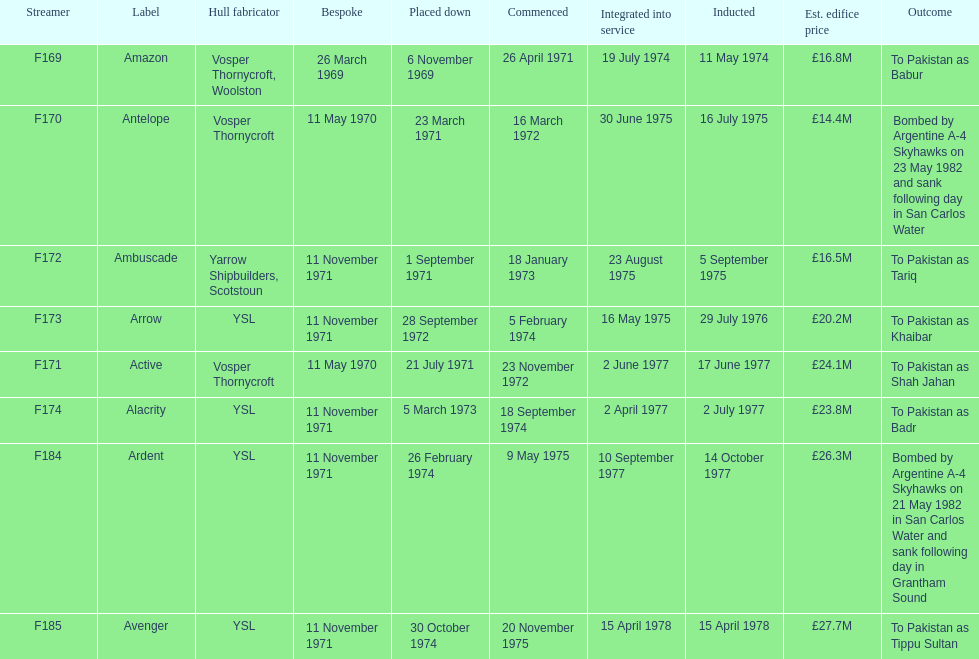The arrow was ordered on november 11, 1971. what was the previous ship? Ambuscade. 